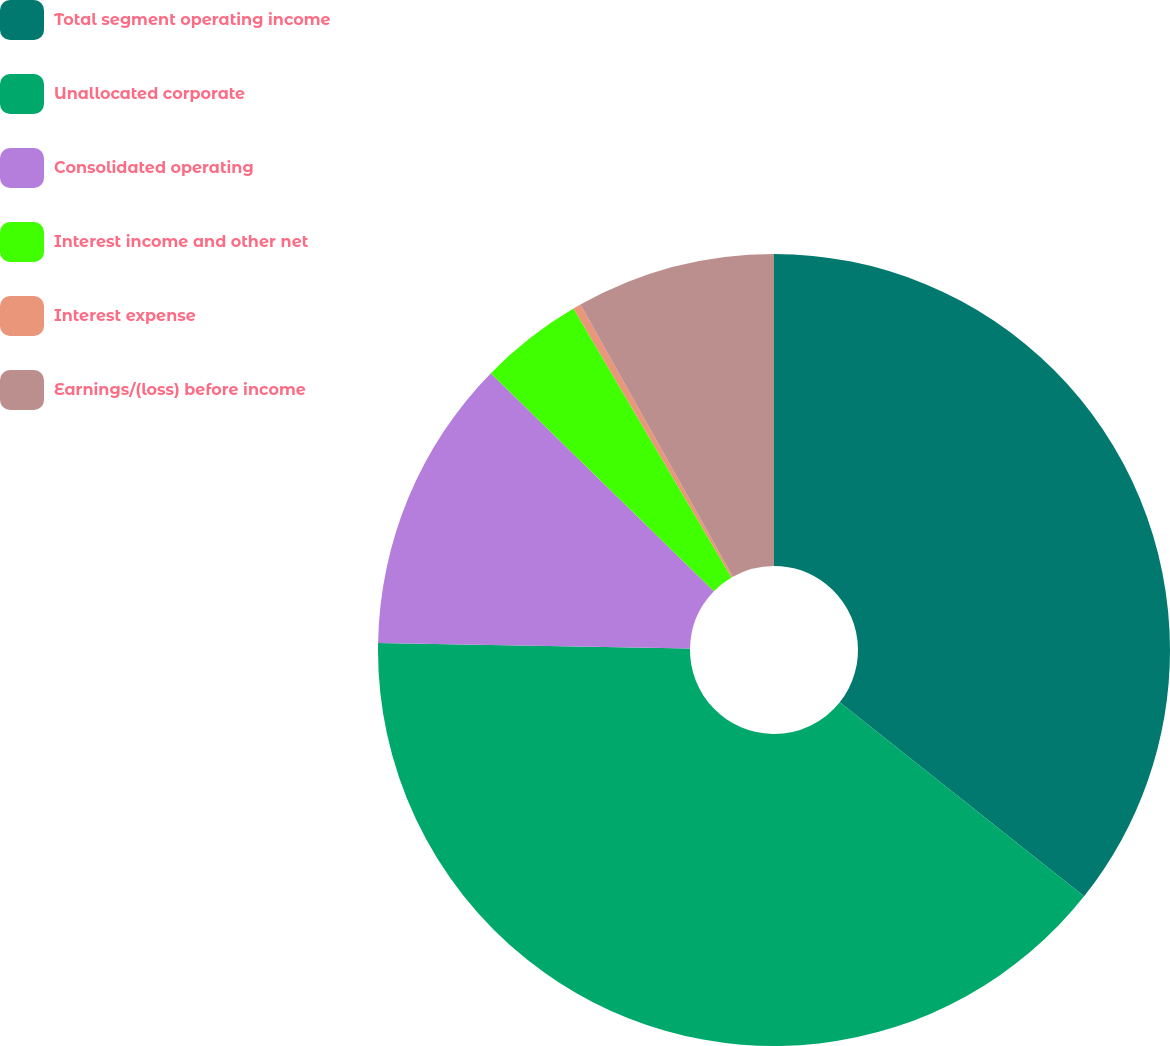Convert chart to OTSL. <chart><loc_0><loc_0><loc_500><loc_500><pie_chart><fcel>Total segment operating income<fcel>Unallocated corporate<fcel>Consolidated operating<fcel>Interest income and other net<fcel>Interest expense<fcel>Earnings/(loss) before income<nl><fcel>35.68%<fcel>39.59%<fcel>12.04%<fcel>4.23%<fcel>0.32%<fcel>8.13%<nl></chart> 